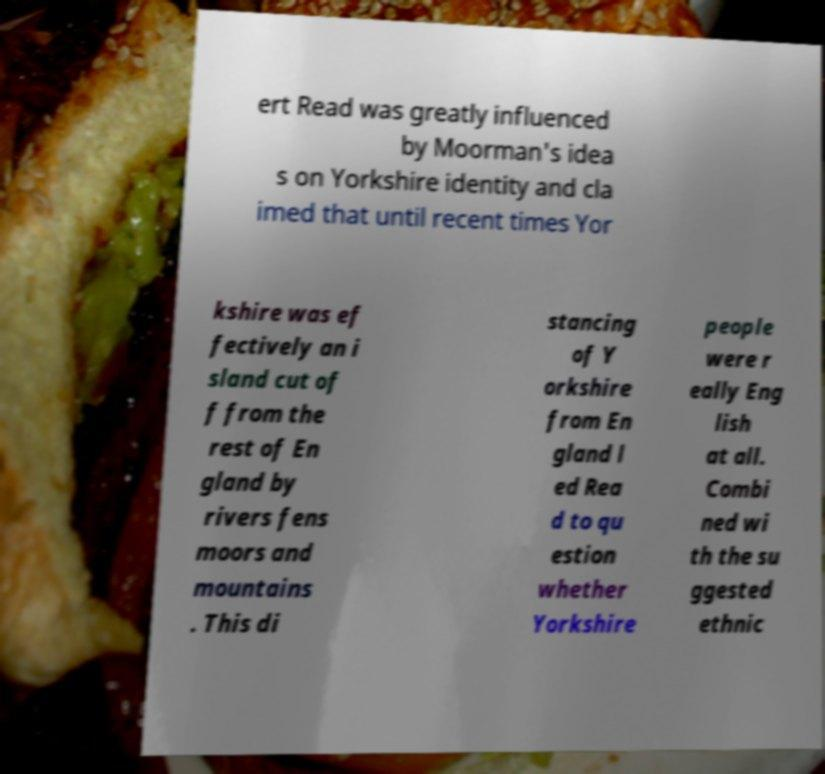What messages or text are displayed in this image? I need them in a readable, typed format. ert Read was greatly influenced by Moorman's idea s on Yorkshire identity and cla imed that until recent times Yor kshire was ef fectively an i sland cut of f from the rest of En gland by rivers fens moors and mountains . This di stancing of Y orkshire from En gland l ed Rea d to qu estion whether Yorkshire people were r eally Eng lish at all. Combi ned wi th the su ggested ethnic 